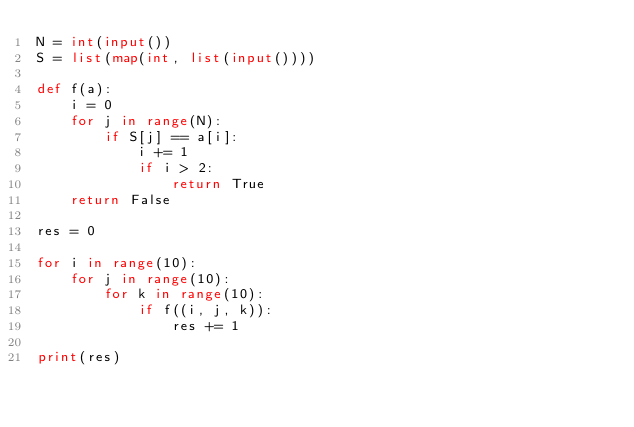<code> <loc_0><loc_0><loc_500><loc_500><_Python_>N = int(input())
S = list(map(int, list(input())))

def f(a):
    i = 0
    for j in range(N):
        if S[j] == a[i]:
            i += 1
            if i > 2:
                return True
    return False

res = 0

for i in range(10):
    for j in range(10):
        for k in range(10):
            if f((i, j, k)):
                res += 1

print(res)</code> 